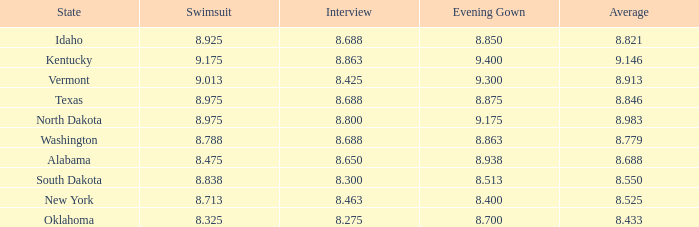What is the lowest average of the contestant with an interview of 8.275 and an evening gown bigger than 8.7? None. 